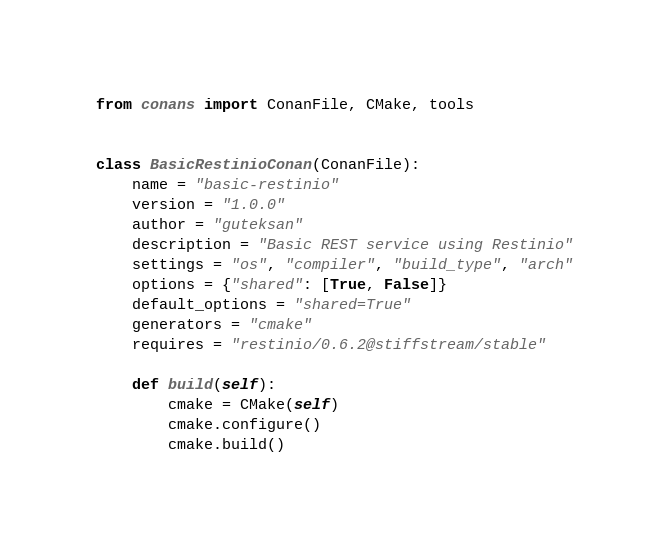<code> <loc_0><loc_0><loc_500><loc_500><_Python_>from conans import ConanFile, CMake, tools


class BasicRestinioConan(ConanFile):
    name = "basic-restinio"
    version = "1.0.0"
    author = "guteksan"
    description = "Basic REST service using Restinio"
    settings = "os", "compiler", "build_type", "arch"
    options = {"shared": [True, False]}
    default_options = "shared=True"
    generators = "cmake"
    requires = "restinio/0.6.2@stiffstream/stable"

    def build(self):
        cmake = CMake(self)
        cmake.configure()
        cmake.build()


</code> 